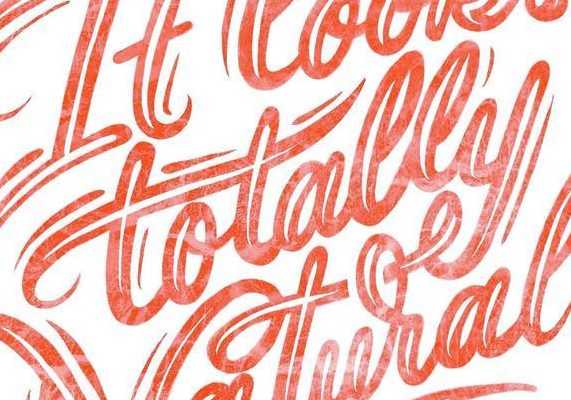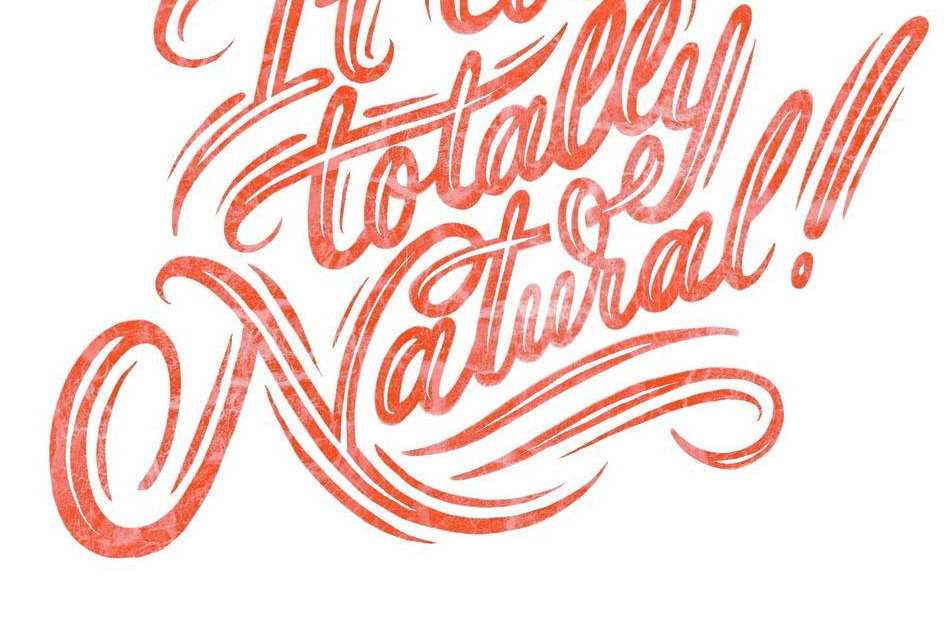What text is displayed in these images sequentially, separated by a semicolon? totally; Natural! 